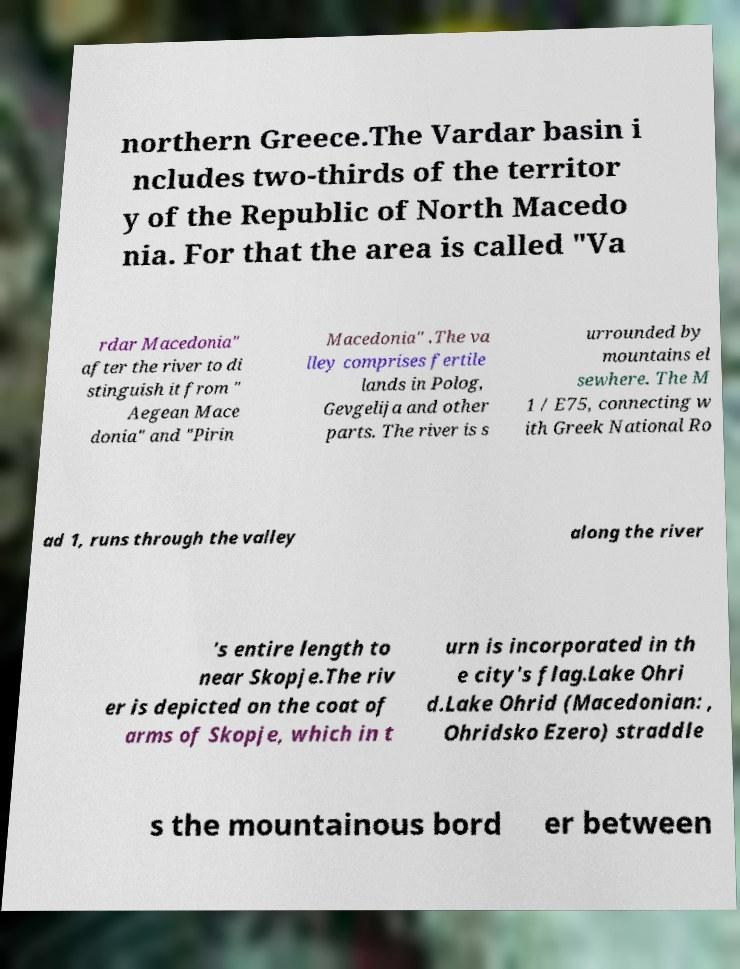Can you accurately transcribe the text from the provided image for me? northern Greece.The Vardar basin i ncludes two-thirds of the territor y of the Republic of North Macedo nia. For that the area is called "Va rdar Macedonia" after the river to di stinguish it from " Aegean Mace donia" and "Pirin Macedonia" .The va lley comprises fertile lands in Polog, Gevgelija and other parts. The river is s urrounded by mountains el sewhere. The M 1 / E75, connecting w ith Greek National Ro ad 1, runs through the valley along the river 's entire length to near Skopje.The riv er is depicted on the coat of arms of Skopje, which in t urn is incorporated in th e city's flag.Lake Ohri d.Lake Ohrid (Macedonian: , Ohridsko Ezero) straddle s the mountainous bord er between 